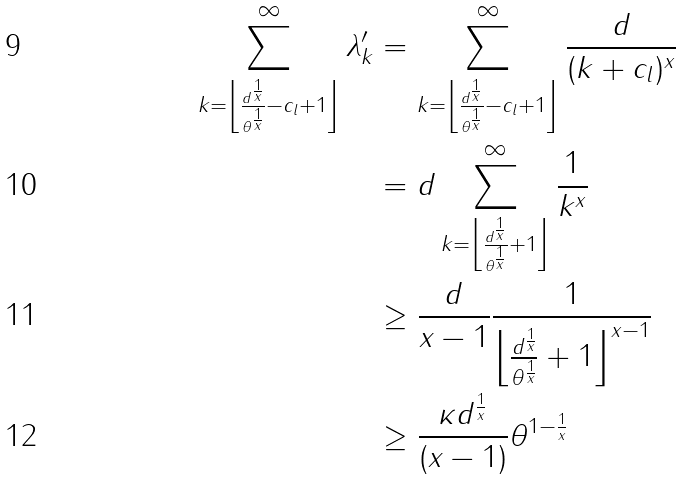<formula> <loc_0><loc_0><loc_500><loc_500>\sum _ { k = \left \lfloor \frac { d ^ { \frac { 1 } { x } } } { \theta ^ { \frac { 1 } { x } } } - c _ { l } + 1 \right \rfloor } ^ { \infty } \lambda _ { k } ^ { \prime } & = \sum _ { k = \left \lfloor \frac { d ^ { \frac { 1 } { x } } } { \theta ^ { \frac { 1 } { x } } } - c _ { l } + 1 \right \rfloor } ^ { \infty } \frac { d } { ( k + c _ { l } ) ^ { x } } \\ & = d \sum _ { k = \left \lfloor \frac { d ^ { \frac { 1 } { x } } } { \theta ^ { \frac { 1 } { x } } } + 1 \right \rfloor } ^ { \infty } \frac { 1 } { k ^ { x } } \\ & \geq \frac { d } { x - 1 } \frac { 1 } { \left \lfloor \frac { d ^ { \frac { 1 } { x } } } { \theta ^ { \frac { 1 } { x } } } + 1 \right \rfloor ^ { x - 1 } } \\ & \geq \frac { \kappa d ^ { \frac { 1 } { x } } } { ( x - 1 ) } \theta ^ { 1 - \frac { 1 } { x } }</formula> 